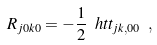<formula> <loc_0><loc_0><loc_500><loc_500>R _ { j 0 k 0 } = - \frac { 1 } { 2 } \ h t t _ { j k , 0 0 } \ ,</formula> 